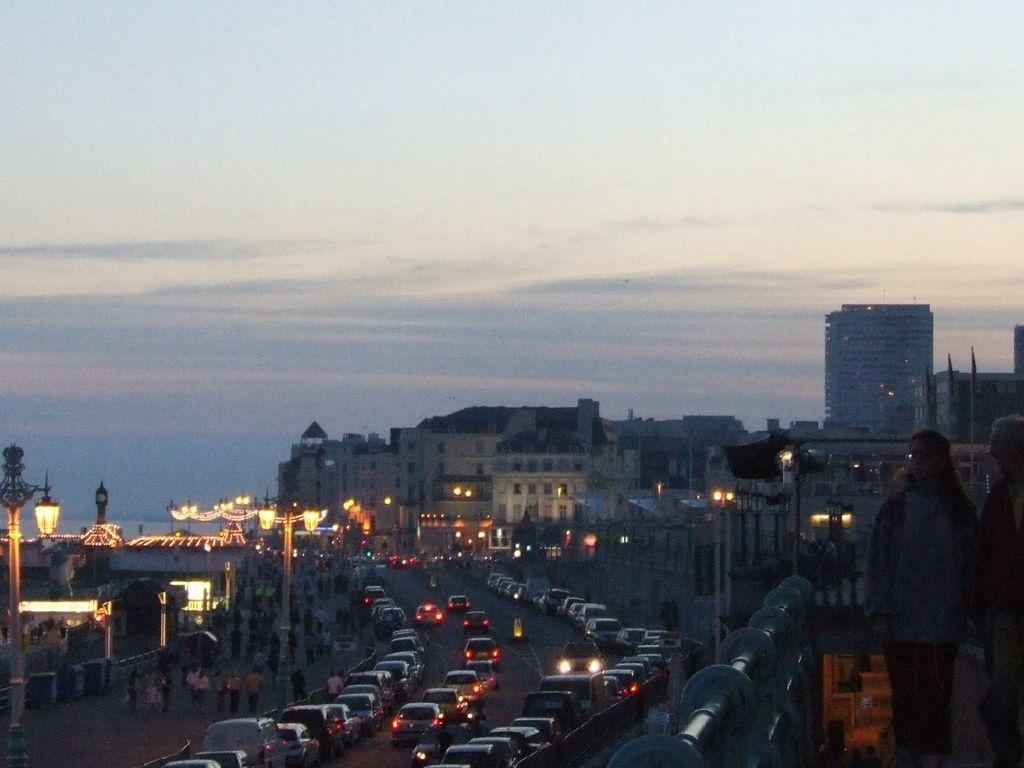What can be seen on the right side of the image? There are people on the right side of the image. What separates the people from the rest of the image? There is a boundary on the right side of the image. What is located in the foreground of the image? There are vehicles, light, and buildings in the foreground of the image. What is visible in the background of the image? The sky is visible in the background of the image. How many ladybugs are present on the vehicles in the image? There are no ladybugs present on the vehicles in the image. What day of the week is depicted in the image? The image does not depict a specific day of the week. 